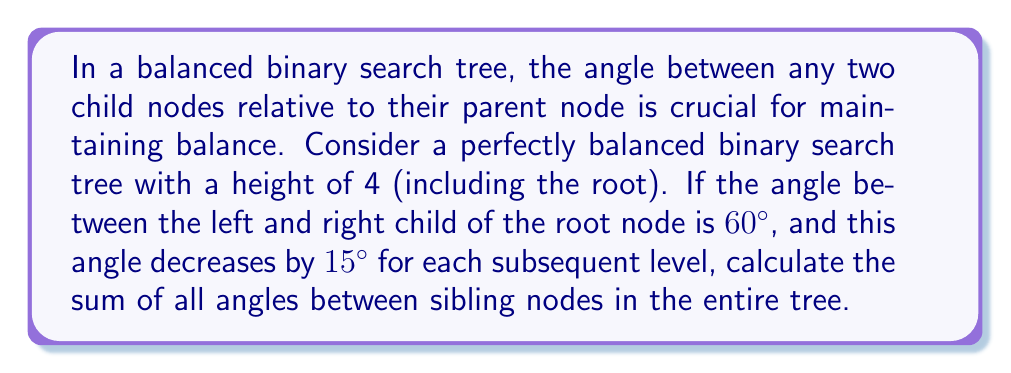Provide a solution to this math problem. Let's approach this step-by-step:

1) First, let's visualize the tree:

[asy]
unitsize(1cm);

pair[] nodes = {(0,0), (-2,-2), (2,-2), (-3,-4), (-1,-4), (1,-4), (3,-4)};
for(int i=0; i<7; ++i) {
  dot(nodes[i]);
}

draw(nodes[0]--nodes[1]);
draw(nodes[0]--nodes[2]);
draw(nodes[1]--nodes[3]);
draw(nodes[1]--nodes[4]);
draw(nodes[2]--nodes[5]);
draw(nodes[2]--nodes[6]);

label("60°", (0,0), N);
label("45°", (-2,-2), N);
label("45°", (2,-2), N);
label("30°", (-3,-4), N);
label("30°", (-1,-4), N);
label("30°", (1,-4), N);
label("30°", (3,-4), N);
[/asy]

2) We're given that the angle at the root is 60° and it decreases by 15° for each level.

3) Let's calculate the angles at each level:
   Level 1 (root): 60°
   Level 2: 60° - 15° = 45°
   Level 3: 45° - 15° = 30°
   Level 4: 30° - 15° = 15° (but this level has no children, so we don't count it)

4) Now, let's count the number of these angles at each level:
   Level 1: 1 angle of 60°
   Level 2: 2 angles of 45°
   Level 3: 4 angles of 30°

5) Let's sum these up:
   $$ \text{Total} = (1 \times 60°) + (2 \times 45°) + (4 \times 30°) $$

6) Calculating:
   $$ \text{Total} = 60° + 90° + 120° = 270° $$

Therefore, the sum of all angles between sibling nodes in the entire tree is 270°.
Answer: 270° 